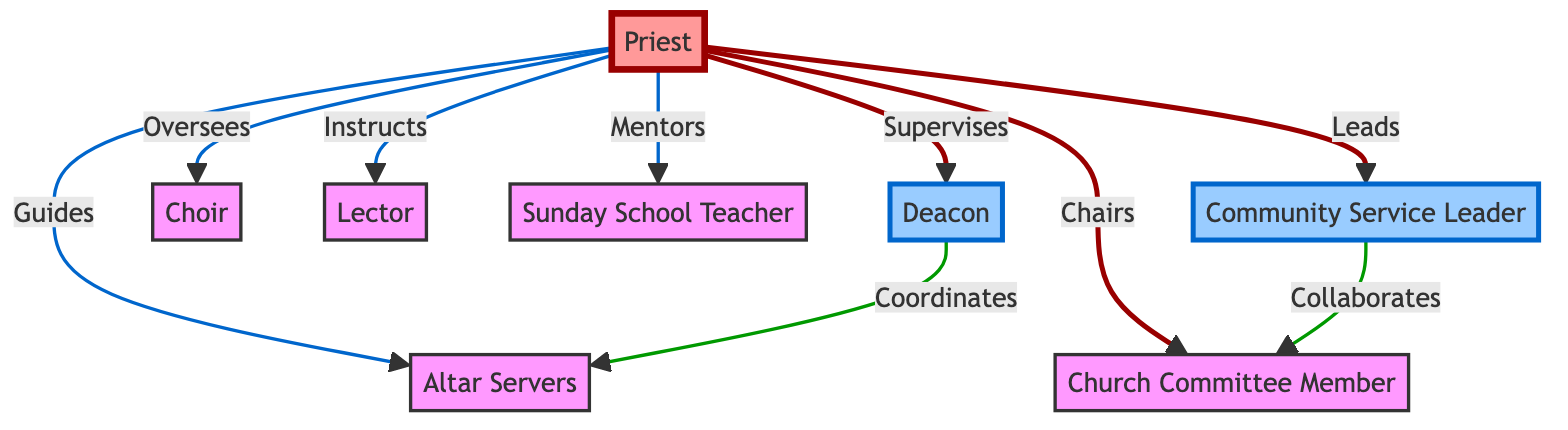What role is directly supervised by the priest? The diagram indicates that the priest supervises the deacon. This is evident as there is a direct link from the priest node to the deacon node labeled "Supervises."
Answer: Deacon How many leadership roles are depicted in the diagram? By counting the nodes categorized under leadership with specific styling, we identify three roles: Deacon, Community Service Leader, and Church Committee Member. Hence, there are three leadership roles.
Answer: 3 What is the role that collaborates with the church committee member? The diagram shows that the Community Service Leader collaborates with the Church Committee Member, as indicated by the link labeled "Collaborates" connecting their respective nodes.
Answer: Community Service Leader Which role is coordinated by the deacon? According to the diagram, the deacon coordinates the altar servers. This is illustrated through the link marked "Coordinates" from the deacon node to the altar servers node.
Answer: Altar Servers What is the relationship indicating that the priest guides the altar servers? The diagram has a direct relationship indicated by the link from the priest node to the altar servers node labeled "Guides." This demonstrates the guiding relationship between these two roles.
Answer: Guides How many total nodes are present in this diagram? The diagram contains eight nodes representing different roles. By counting each unique role depicted, we determine that there are eight nodes in total.
Answer: 8 Which role handles the Sunday School teaching? The diagram presents the Sunday School Teacher role, which is clearly labeled as an individual node without a direct link to others, showcasing its specific function within the parish.
Answer: Sunday School Teacher What role does the priest lead? The priest is indicated as the leader of the Community Service Leader role, as they are linked with the label "Leads." This shows a direct leadership connection.
Answer: Community Service Leader 